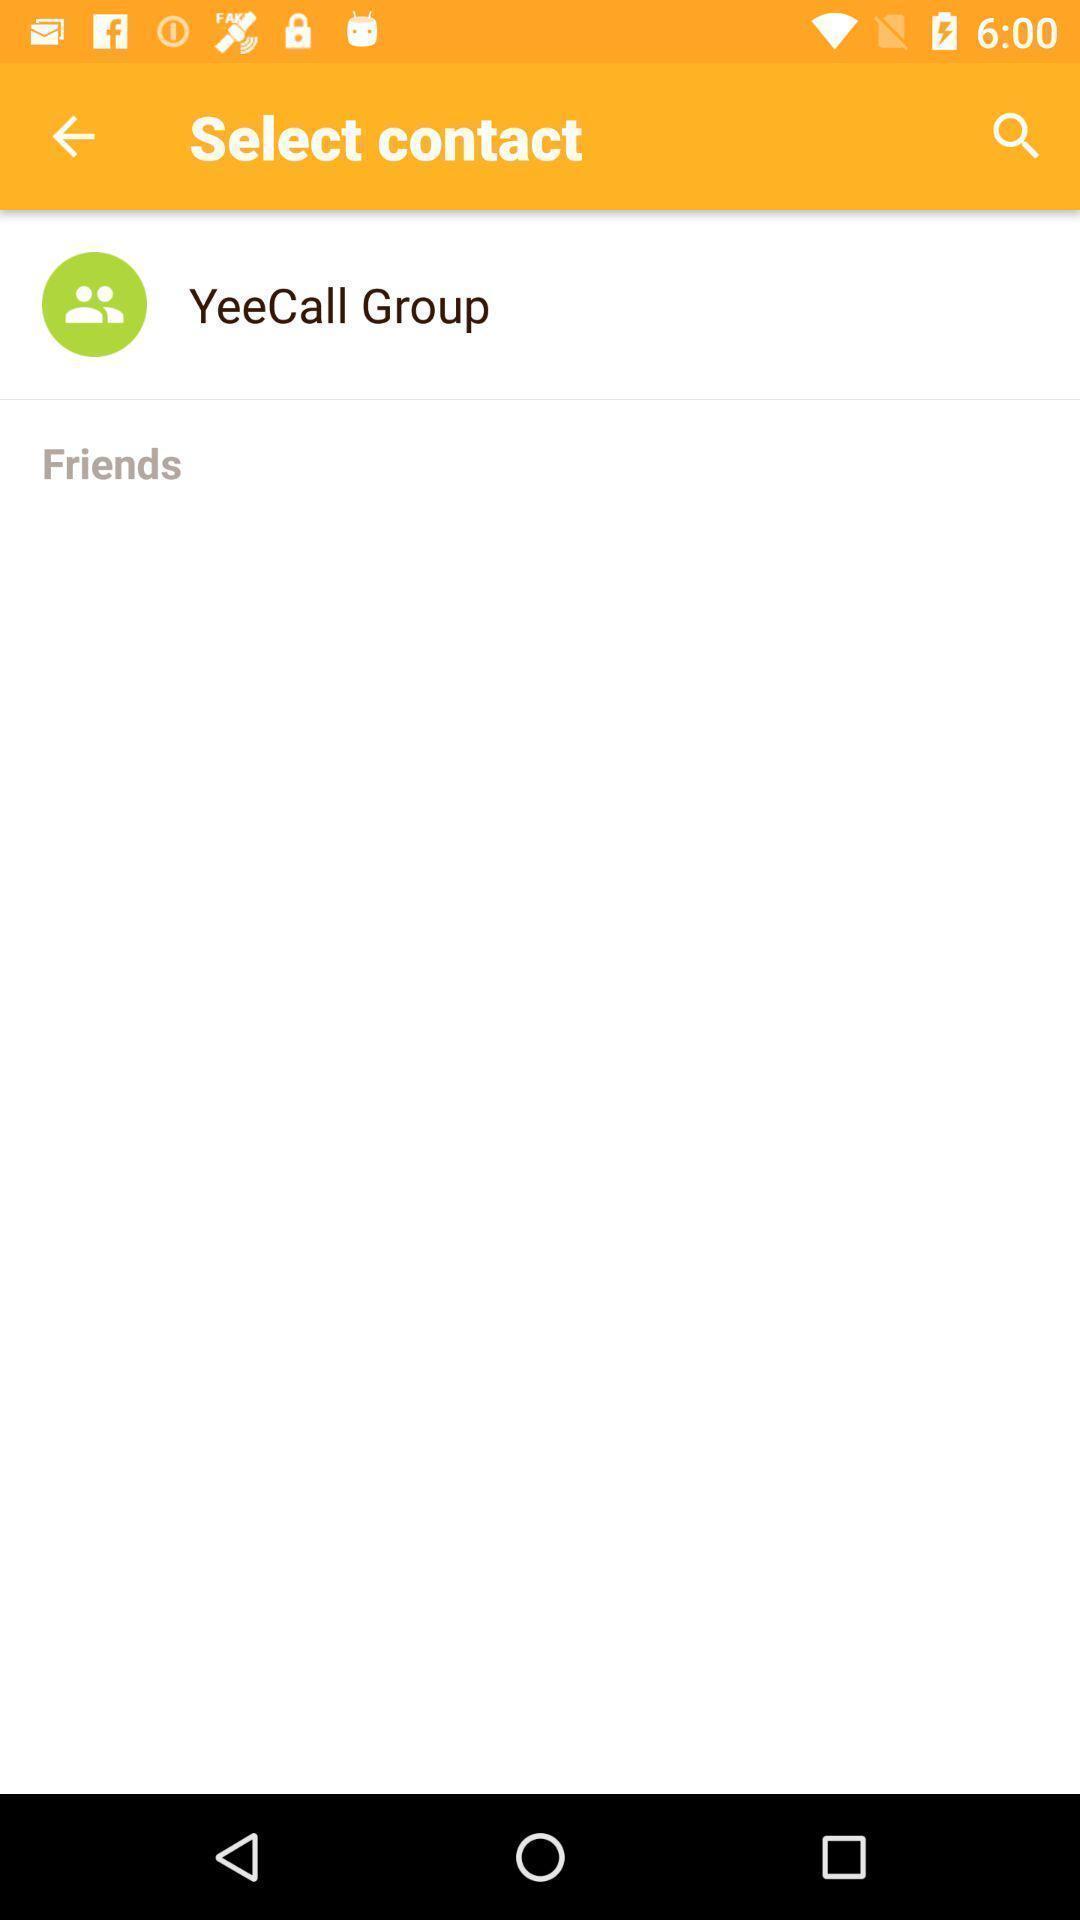Provide a detailed account of this screenshot. Screen showing select contact. 